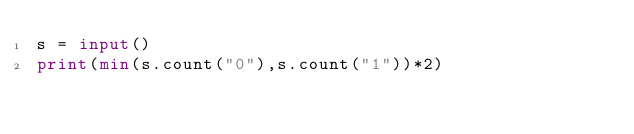Convert code to text. <code><loc_0><loc_0><loc_500><loc_500><_Python_>s = input()
print(min(s.count("0"),s.count("1"))*2)</code> 